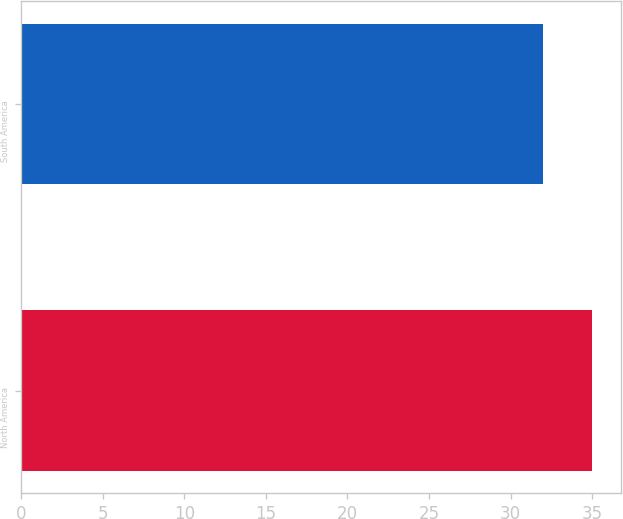Convert chart. <chart><loc_0><loc_0><loc_500><loc_500><bar_chart><fcel>North America<fcel>South America<nl><fcel>35<fcel>32<nl></chart> 